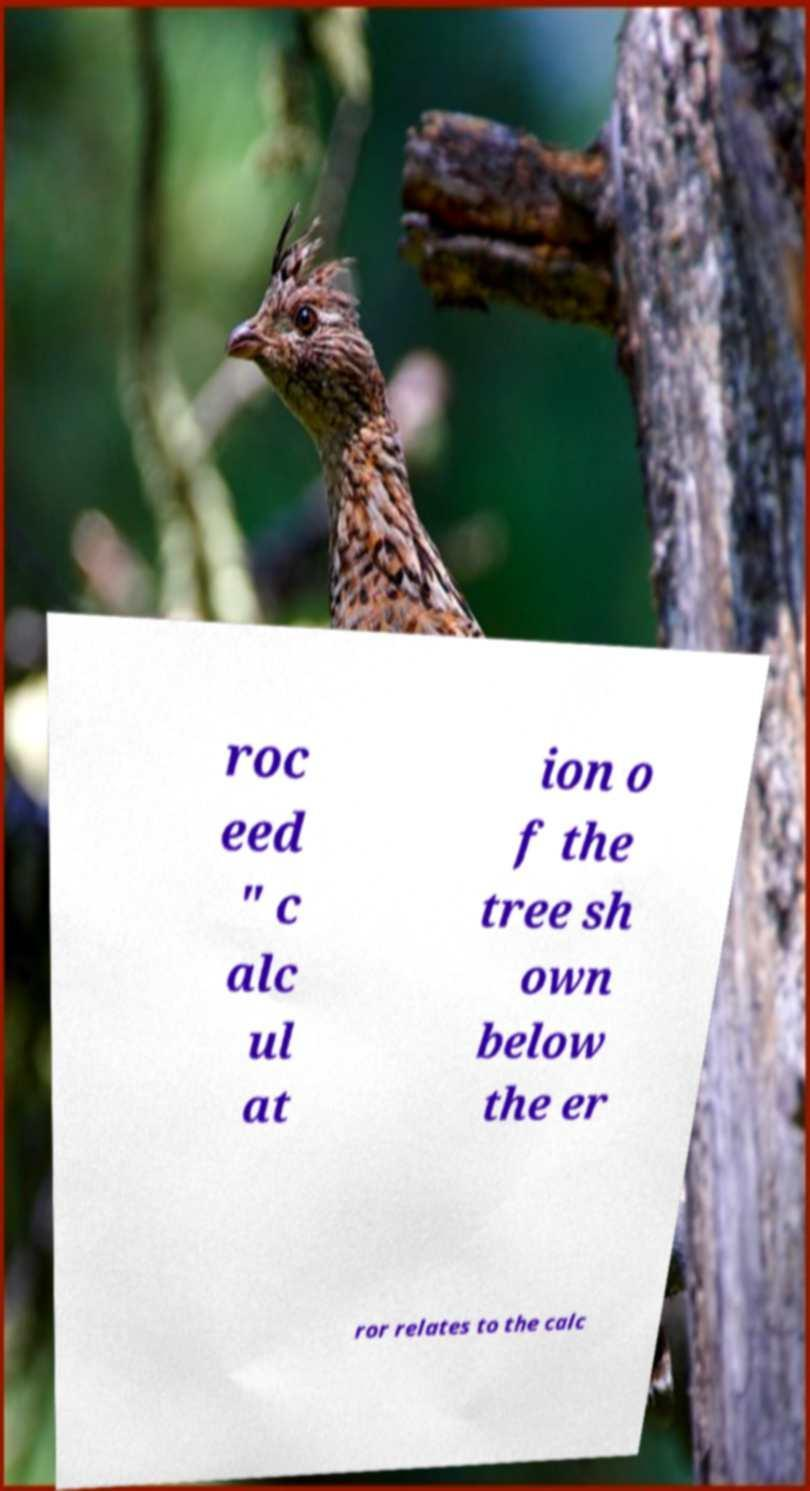Please read and relay the text visible in this image. What does it say? roc eed " c alc ul at ion o f the tree sh own below the er ror relates to the calc 